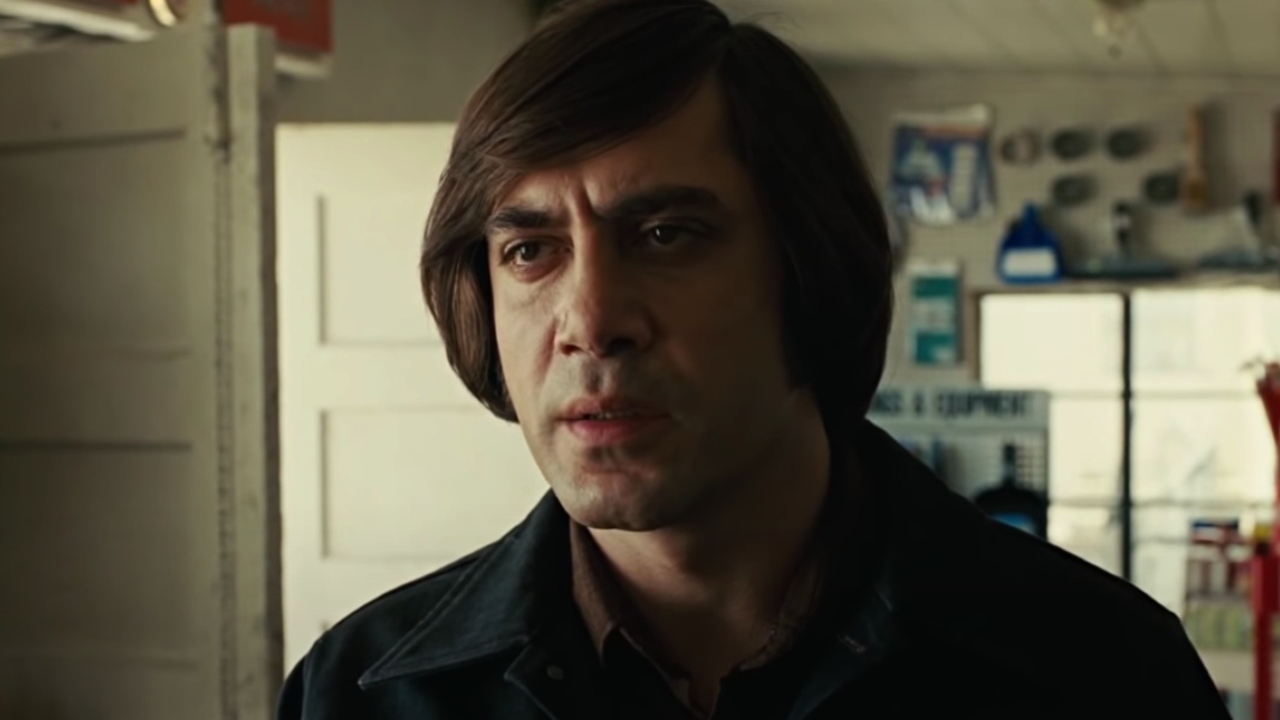What kind of future might await the character? The future for the character is uncertain but full of possibilities. He might find a way to overcome his current struggles, perhaps by expanding his workshop into a successful business that mentors young apprentices. Alternatively, he could decide to close the chapter on his workshop life, moving on to a new career that offers different challenges and rewards. Regardless of the path he chooses, his experiences and skills will guide him toward a meaningful and fulfilling future, enriched by the lessons learned in his workshop. What is the significance of his contemplative expression? His contemplative expression signifies a moment of introspection and decision-making. It indicates the weight of his thoughts, possibly concerning a significant change or challenge in his life. This expression reflects a depth of character, suggesting that he is someone who takes his responsibilities seriously and is not afraid to engage with the difficult aspects of his journey. It adds a layer of humanity and relatability, making him a figure that embodies resilience and determination. Describe a realistic, emotional scenario that might be unfolding at this moment. At this moment, the character might be reflecting on a bittersweet memory of his father, who taught him everything about the trade. Perhaps he just found an old, worn-down tool that belonged to his father, evoking a flood of memories and emotions. The image captures him at the crossroads of grief and gratitude, painfully aware of his loss but also deeply thankful for the legacy that shaped him into the skilled craftsman he is today. This poignant moment serves as a reminder of the love and lessons passed down through generations, grounding him in his mission to uphold his father’s standards of excellence and integrity. Give a brief summary of the image's emotional tone. The image exudes a somber and reflective emotional tone. The character's serious expression and the subdued colors of the workshop setting suggest a moment of deep thought and contemplation. It conveys a narrative of struggle, resilience, and the quiet determination to face whatever challenges lie ahead. 